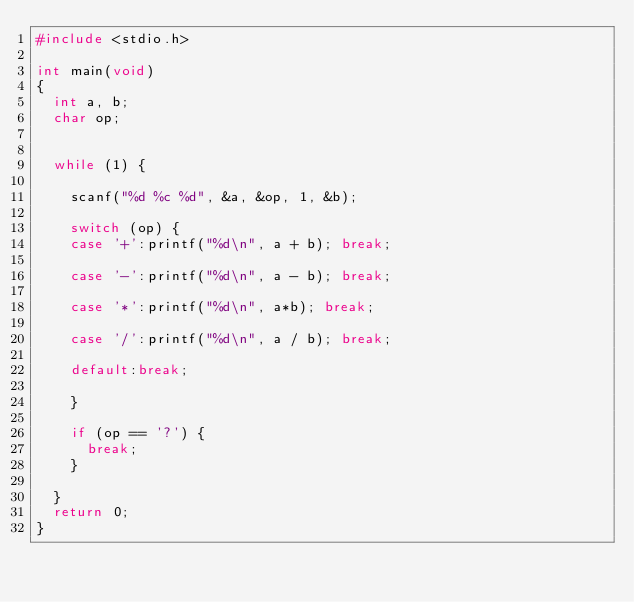Convert code to text. <code><loc_0><loc_0><loc_500><loc_500><_C_>#include <stdio.h>

int main(void)
{
	int a, b;
	char op;


	while (1) {

		scanf("%d %c %d", &a, &op, 1, &b);

		switch (op) {
		case '+':printf("%d\n", a + b); break;

		case '-':printf("%d\n", a - b); break;

		case '*':printf("%d\n", a*b); break;

		case '/':printf("%d\n", a / b); break;

		default:break;

		}

		if (op == '?') {
			break;
		}

	}
	return 0;
}</code> 